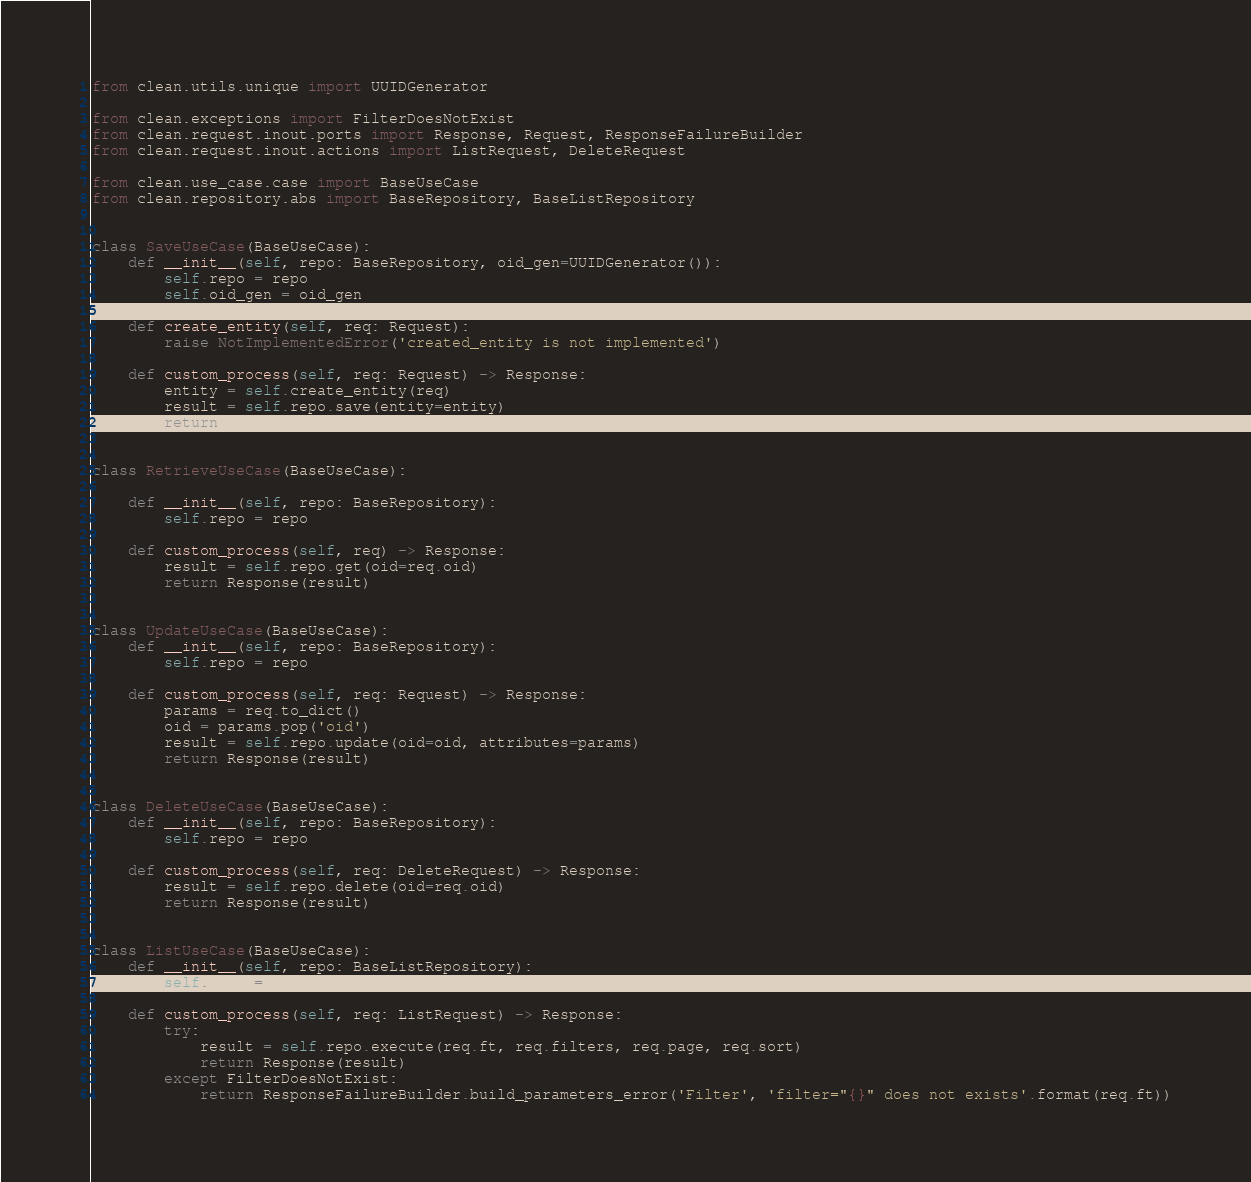<code> <loc_0><loc_0><loc_500><loc_500><_Python_>from clean.utils.unique import UUIDGenerator

from clean.exceptions import FilterDoesNotExist
from clean.request.inout.ports import Response, Request, ResponseFailureBuilder
from clean.request.inout.actions import ListRequest, DeleteRequest

from clean.use_case.case import BaseUseCase
from clean.repository.abs import BaseRepository, BaseListRepository


class SaveUseCase(BaseUseCase):
    def __init__(self, repo: BaseRepository, oid_gen=UUIDGenerator()):
        self.repo = repo
        self.oid_gen = oid_gen

    def create_entity(self, req: Request):
        raise NotImplementedError('created_entity is not implemented')

    def custom_process(self, req: Request) -> Response:
        entity = self.create_entity(req)
        result = self.repo.save(entity=entity)
        return Response(result)


class RetrieveUseCase(BaseUseCase):

    def __init__(self, repo: BaseRepository):
        self.repo = repo

    def custom_process(self, req) -> Response:
        result = self.repo.get(oid=req.oid)
        return Response(result)


class UpdateUseCase(BaseUseCase):
    def __init__(self, repo: BaseRepository):
        self.repo = repo

    def custom_process(self, req: Request) -> Response:
        params = req.to_dict()
        oid = params.pop('oid')
        result = self.repo.update(oid=oid, attributes=params)
        return Response(result)


class DeleteUseCase(BaseUseCase):
    def __init__(self, repo: BaseRepository):
        self.repo = repo

    def custom_process(self, req: DeleteRequest) -> Response:
        result = self.repo.delete(oid=req.oid)
        return Response(result)


class ListUseCase(BaseUseCase):
    def __init__(self, repo: BaseListRepository):
        self.repo = repo

    def custom_process(self, req: ListRequest) -> Response:
        try:
            result = self.repo.execute(req.ft, req.filters, req.page, req.sort)
            return Response(result)
        except FilterDoesNotExist:
            return ResponseFailureBuilder.build_parameters_error('Filter', 'filter="{}" does not exists'.format(req.ft))
</code> 